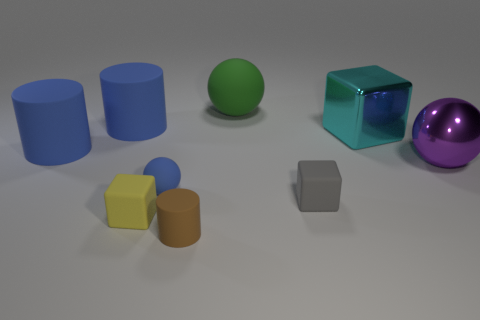Is the number of large matte things that are right of the big rubber ball greater than the number of large blue rubber cylinders that are on the right side of the small yellow thing?
Keep it short and to the point. No. How big is the yellow thing?
Make the answer very short. Small. Is there a large rubber thing that has the same shape as the small gray rubber object?
Your response must be concise. No. There is a big purple thing; is it the same shape as the tiny rubber object that is behind the tiny gray rubber object?
Provide a succinct answer. Yes. There is a thing that is in front of the big green object and behind the big shiny block; what is its size?
Provide a succinct answer. Large. How many matte cubes are there?
Give a very brief answer. 2. What is the material of the gray thing that is the same size as the brown cylinder?
Provide a succinct answer. Rubber. Is there a shiny cube of the same size as the yellow object?
Keep it short and to the point. No. There is a small block to the right of the green rubber ball; is its color the same as the cube that is behind the small sphere?
Provide a short and direct response. No. How many rubber things are large blocks or large brown blocks?
Give a very brief answer. 0. 